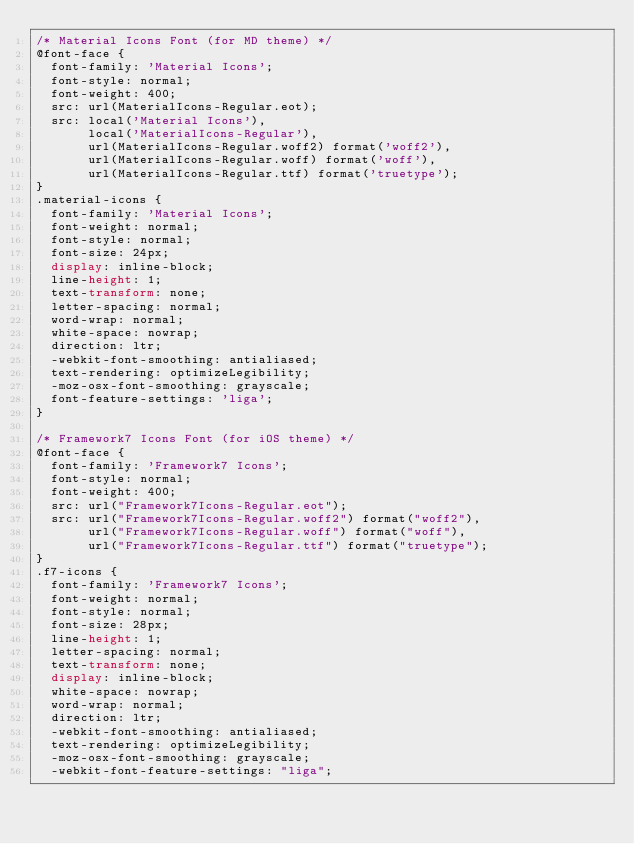Convert code to text. <code><loc_0><loc_0><loc_500><loc_500><_CSS_>/* Material Icons Font (for MD theme) */
@font-face {
  font-family: 'Material Icons';
  font-style: normal;
  font-weight: 400;
  src: url(MaterialIcons-Regular.eot);
  src: local('Material Icons'),
       local('MaterialIcons-Regular'),
       url(MaterialIcons-Regular.woff2) format('woff2'),
       url(MaterialIcons-Regular.woff) format('woff'),
       url(MaterialIcons-Regular.ttf) format('truetype');
}
.material-icons {
  font-family: 'Material Icons';
  font-weight: normal;
  font-style: normal;
  font-size: 24px;
  display: inline-block;
  line-height: 1;
  text-transform: none;
  letter-spacing: normal;
  word-wrap: normal;
  white-space: nowrap;
  direction: ltr;
  -webkit-font-smoothing: antialiased;
  text-rendering: optimizeLegibility;
  -moz-osx-font-smoothing: grayscale;
  font-feature-settings: 'liga';
}

/* Framework7 Icons Font (for iOS theme) */
@font-face {
  font-family: 'Framework7 Icons';
  font-style: normal;
  font-weight: 400;
  src: url("Framework7Icons-Regular.eot");
  src: url("Framework7Icons-Regular.woff2") format("woff2"),
       url("Framework7Icons-Regular.woff") format("woff"),
       url("Framework7Icons-Regular.ttf") format("truetype");
}
.f7-icons {
  font-family: 'Framework7 Icons';
  font-weight: normal;
  font-style: normal;
  font-size: 28px;
  line-height: 1;
  letter-spacing: normal;
  text-transform: none;
  display: inline-block;
  white-space: nowrap;
  word-wrap: normal;
  direction: ltr;
  -webkit-font-smoothing: antialiased;
  text-rendering: optimizeLegibility;
  -moz-osx-font-smoothing: grayscale;
  -webkit-font-feature-settings: "liga";</code> 